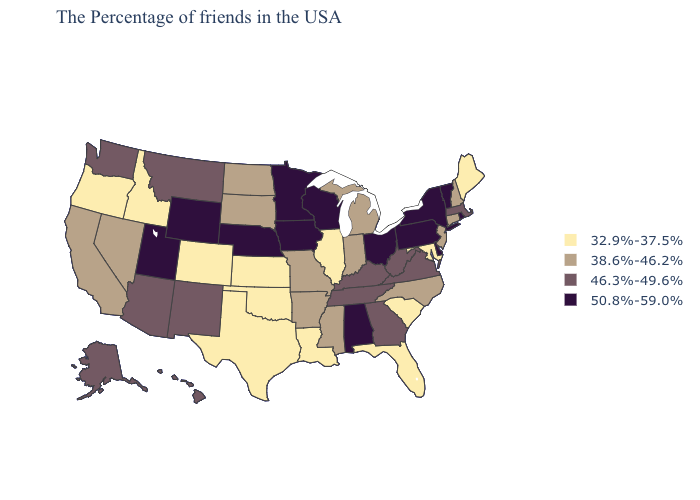Name the states that have a value in the range 38.6%-46.2%?
Concise answer only. New Hampshire, Connecticut, New Jersey, North Carolina, Michigan, Indiana, Mississippi, Missouri, Arkansas, South Dakota, North Dakota, Nevada, California. What is the highest value in the USA?
Answer briefly. 50.8%-59.0%. Does Idaho have the lowest value in the USA?
Concise answer only. Yes. Does Colorado have a higher value than California?
Be succinct. No. Does Utah have the highest value in the USA?
Keep it brief. Yes. Name the states that have a value in the range 38.6%-46.2%?
Give a very brief answer. New Hampshire, Connecticut, New Jersey, North Carolina, Michigan, Indiana, Mississippi, Missouri, Arkansas, South Dakota, North Dakota, Nevada, California. Among the states that border South Carolina , which have the lowest value?
Keep it brief. North Carolina. What is the value of New Mexico?
Short answer required. 46.3%-49.6%. What is the lowest value in the MidWest?
Answer briefly. 32.9%-37.5%. What is the highest value in states that border North Carolina?
Give a very brief answer. 46.3%-49.6%. Name the states that have a value in the range 46.3%-49.6%?
Short answer required. Massachusetts, Virginia, West Virginia, Georgia, Kentucky, Tennessee, New Mexico, Montana, Arizona, Washington, Alaska, Hawaii. Does South Carolina have the lowest value in the South?
Concise answer only. Yes. Does Missouri have the lowest value in the USA?
Answer briefly. No. Which states have the lowest value in the USA?
Give a very brief answer. Maine, Maryland, South Carolina, Florida, Illinois, Louisiana, Kansas, Oklahoma, Texas, Colorado, Idaho, Oregon. Is the legend a continuous bar?
Answer briefly. No. 